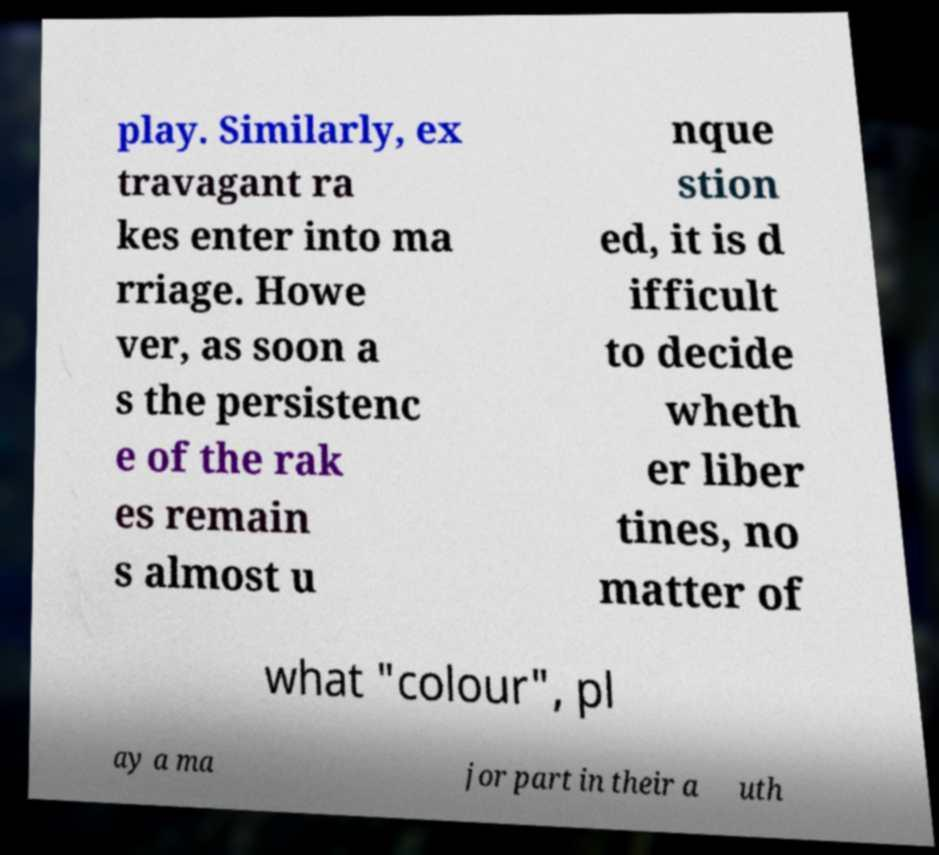What messages or text are displayed in this image? I need them in a readable, typed format. play. Similarly, ex travagant ra kes enter into ma rriage. Howe ver, as soon a s the persistenc e of the rak es remain s almost u nque stion ed, it is d ifficult to decide wheth er liber tines, no matter of what "colour", pl ay a ma jor part in their a uth 